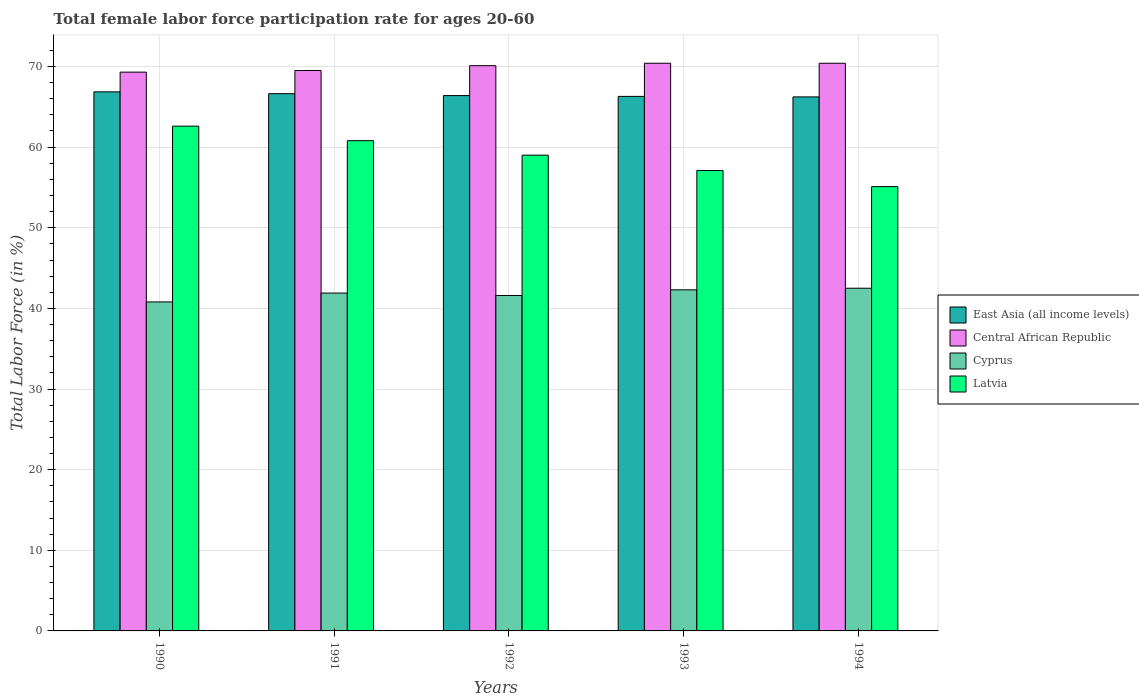How many different coloured bars are there?
Keep it short and to the point. 4. What is the label of the 1st group of bars from the left?
Make the answer very short. 1990. What is the female labor force participation rate in Central African Republic in 1992?
Your answer should be very brief. 70.1. Across all years, what is the maximum female labor force participation rate in Latvia?
Provide a succinct answer. 62.6. Across all years, what is the minimum female labor force participation rate in East Asia (all income levels)?
Make the answer very short. 66.23. In which year was the female labor force participation rate in Latvia maximum?
Provide a succinct answer. 1990. What is the total female labor force participation rate in Central African Republic in the graph?
Ensure brevity in your answer.  349.7. What is the difference between the female labor force participation rate in East Asia (all income levels) in 1991 and that in 1993?
Provide a succinct answer. 0.34. What is the difference between the female labor force participation rate in Cyprus in 1993 and the female labor force participation rate in Central African Republic in 1994?
Ensure brevity in your answer.  -28.1. What is the average female labor force participation rate in Latvia per year?
Give a very brief answer. 58.92. In the year 1992, what is the difference between the female labor force participation rate in East Asia (all income levels) and female labor force participation rate in Latvia?
Provide a short and direct response. 7.39. In how many years, is the female labor force participation rate in East Asia (all income levels) greater than 60 %?
Offer a very short reply. 5. What is the ratio of the female labor force participation rate in Central African Republic in 1991 to that in 1994?
Your answer should be compact. 0.99. Is the female labor force participation rate in East Asia (all income levels) in 1991 less than that in 1992?
Ensure brevity in your answer.  No. What is the difference between the highest and the second highest female labor force participation rate in East Asia (all income levels)?
Provide a succinct answer. 0.22. What is the difference between the highest and the lowest female labor force participation rate in Central African Republic?
Ensure brevity in your answer.  1.1. In how many years, is the female labor force participation rate in Central African Republic greater than the average female labor force participation rate in Central African Republic taken over all years?
Your answer should be very brief. 3. What does the 1st bar from the left in 1991 represents?
Keep it short and to the point. East Asia (all income levels). What does the 4th bar from the right in 1990 represents?
Offer a terse response. East Asia (all income levels). Are all the bars in the graph horizontal?
Provide a short and direct response. No. What is the difference between two consecutive major ticks on the Y-axis?
Provide a succinct answer. 10. Are the values on the major ticks of Y-axis written in scientific E-notation?
Offer a terse response. No. Does the graph contain any zero values?
Offer a very short reply. No. Where does the legend appear in the graph?
Your answer should be compact. Center right. How are the legend labels stacked?
Give a very brief answer. Vertical. What is the title of the graph?
Ensure brevity in your answer.  Total female labor force participation rate for ages 20-60. Does "Sao Tome and Principe" appear as one of the legend labels in the graph?
Offer a terse response. No. What is the Total Labor Force (in %) in East Asia (all income levels) in 1990?
Offer a very short reply. 66.85. What is the Total Labor Force (in %) of Central African Republic in 1990?
Your answer should be compact. 69.3. What is the Total Labor Force (in %) of Cyprus in 1990?
Provide a short and direct response. 40.8. What is the Total Labor Force (in %) of Latvia in 1990?
Give a very brief answer. 62.6. What is the Total Labor Force (in %) of East Asia (all income levels) in 1991?
Give a very brief answer. 66.63. What is the Total Labor Force (in %) in Central African Republic in 1991?
Your answer should be very brief. 69.5. What is the Total Labor Force (in %) in Cyprus in 1991?
Provide a short and direct response. 41.9. What is the Total Labor Force (in %) of Latvia in 1991?
Provide a succinct answer. 60.8. What is the Total Labor Force (in %) of East Asia (all income levels) in 1992?
Ensure brevity in your answer.  66.39. What is the Total Labor Force (in %) of Central African Republic in 1992?
Your answer should be compact. 70.1. What is the Total Labor Force (in %) of Cyprus in 1992?
Give a very brief answer. 41.6. What is the Total Labor Force (in %) in Latvia in 1992?
Your answer should be compact. 59. What is the Total Labor Force (in %) in East Asia (all income levels) in 1993?
Your answer should be very brief. 66.29. What is the Total Labor Force (in %) in Central African Republic in 1993?
Keep it short and to the point. 70.4. What is the Total Labor Force (in %) of Cyprus in 1993?
Provide a short and direct response. 42.3. What is the Total Labor Force (in %) of Latvia in 1993?
Your answer should be very brief. 57.1. What is the Total Labor Force (in %) of East Asia (all income levels) in 1994?
Keep it short and to the point. 66.23. What is the Total Labor Force (in %) of Central African Republic in 1994?
Keep it short and to the point. 70.4. What is the Total Labor Force (in %) of Cyprus in 1994?
Provide a short and direct response. 42.5. What is the Total Labor Force (in %) of Latvia in 1994?
Your answer should be compact. 55.1. Across all years, what is the maximum Total Labor Force (in %) of East Asia (all income levels)?
Ensure brevity in your answer.  66.85. Across all years, what is the maximum Total Labor Force (in %) in Central African Republic?
Offer a very short reply. 70.4. Across all years, what is the maximum Total Labor Force (in %) in Cyprus?
Make the answer very short. 42.5. Across all years, what is the maximum Total Labor Force (in %) of Latvia?
Offer a very short reply. 62.6. Across all years, what is the minimum Total Labor Force (in %) of East Asia (all income levels)?
Ensure brevity in your answer.  66.23. Across all years, what is the minimum Total Labor Force (in %) of Central African Republic?
Provide a short and direct response. 69.3. Across all years, what is the minimum Total Labor Force (in %) of Cyprus?
Your answer should be very brief. 40.8. Across all years, what is the minimum Total Labor Force (in %) of Latvia?
Keep it short and to the point. 55.1. What is the total Total Labor Force (in %) in East Asia (all income levels) in the graph?
Your answer should be very brief. 332.39. What is the total Total Labor Force (in %) of Central African Republic in the graph?
Your response must be concise. 349.7. What is the total Total Labor Force (in %) of Cyprus in the graph?
Provide a short and direct response. 209.1. What is the total Total Labor Force (in %) of Latvia in the graph?
Give a very brief answer. 294.6. What is the difference between the Total Labor Force (in %) of East Asia (all income levels) in 1990 and that in 1991?
Offer a very short reply. 0.22. What is the difference between the Total Labor Force (in %) in Central African Republic in 1990 and that in 1991?
Your answer should be compact. -0.2. What is the difference between the Total Labor Force (in %) in East Asia (all income levels) in 1990 and that in 1992?
Provide a short and direct response. 0.46. What is the difference between the Total Labor Force (in %) in Latvia in 1990 and that in 1992?
Your answer should be compact. 3.6. What is the difference between the Total Labor Force (in %) in East Asia (all income levels) in 1990 and that in 1993?
Make the answer very short. 0.56. What is the difference between the Total Labor Force (in %) of Central African Republic in 1990 and that in 1993?
Offer a very short reply. -1.1. What is the difference between the Total Labor Force (in %) of Cyprus in 1990 and that in 1993?
Offer a terse response. -1.5. What is the difference between the Total Labor Force (in %) in East Asia (all income levels) in 1990 and that in 1994?
Provide a succinct answer. 0.62. What is the difference between the Total Labor Force (in %) in Central African Republic in 1990 and that in 1994?
Keep it short and to the point. -1.1. What is the difference between the Total Labor Force (in %) of Cyprus in 1990 and that in 1994?
Your response must be concise. -1.7. What is the difference between the Total Labor Force (in %) of East Asia (all income levels) in 1991 and that in 1992?
Your response must be concise. 0.24. What is the difference between the Total Labor Force (in %) in Cyprus in 1991 and that in 1992?
Your answer should be very brief. 0.3. What is the difference between the Total Labor Force (in %) of Latvia in 1991 and that in 1992?
Your response must be concise. 1.8. What is the difference between the Total Labor Force (in %) of East Asia (all income levels) in 1991 and that in 1993?
Offer a terse response. 0.34. What is the difference between the Total Labor Force (in %) of Latvia in 1991 and that in 1993?
Keep it short and to the point. 3.7. What is the difference between the Total Labor Force (in %) of East Asia (all income levels) in 1991 and that in 1994?
Provide a succinct answer. 0.4. What is the difference between the Total Labor Force (in %) of Cyprus in 1991 and that in 1994?
Offer a terse response. -0.6. What is the difference between the Total Labor Force (in %) of East Asia (all income levels) in 1992 and that in 1993?
Offer a very short reply. 0.1. What is the difference between the Total Labor Force (in %) of Latvia in 1992 and that in 1993?
Offer a very short reply. 1.9. What is the difference between the Total Labor Force (in %) in East Asia (all income levels) in 1992 and that in 1994?
Ensure brevity in your answer.  0.16. What is the difference between the Total Labor Force (in %) in Central African Republic in 1992 and that in 1994?
Provide a succinct answer. -0.3. What is the difference between the Total Labor Force (in %) of Latvia in 1992 and that in 1994?
Offer a terse response. 3.9. What is the difference between the Total Labor Force (in %) of East Asia (all income levels) in 1993 and that in 1994?
Provide a short and direct response. 0.06. What is the difference between the Total Labor Force (in %) in Latvia in 1993 and that in 1994?
Provide a succinct answer. 2. What is the difference between the Total Labor Force (in %) of East Asia (all income levels) in 1990 and the Total Labor Force (in %) of Central African Republic in 1991?
Give a very brief answer. -2.65. What is the difference between the Total Labor Force (in %) in East Asia (all income levels) in 1990 and the Total Labor Force (in %) in Cyprus in 1991?
Ensure brevity in your answer.  24.95. What is the difference between the Total Labor Force (in %) of East Asia (all income levels) in 1990 and the Total Labor Force (in %) of Latvia in 1991?
Keep it short and to the point. 6.05. What is the difference between the Total Labor Force (in %) of Central African Republic in 1990 and the Total Labor Force (in %) of Cyprus in 1991?
Your answer should be very brief. 27.4. What is the difference between the Total Labor Force (in %) of Cyprus in 1990 and the Total Labor Force (in %) of Latvia in 1991?
Your response must be concise. -20. What is the difference between the Total Labor Force (in %) in East Asia (all income levels) in 1990 and the Total Labor Force (in %) in Central African Republic in 1992?
Provide a succinct answer. -3.25. What is the difference between the Total Labor Force (in %) of East Asia (all income levels) in 1990 and the Total Labor Force (in %) of Cyprus in 1992?
Your answer should be compact. 25.25. What is the difference between the Total Labor Force (in %) in East Asia (all income levels) in 1990 and the Total Labor Force (in %) in Latvia in 1992?
Give a very brief answer. 7.85. What is the difference between the Total Labor Force (in %) in Central African Republic in 1990 and the Total Labor Force (in %) in Cyprus in 1992?
Give a very brief answer. 27.7. What is the difference between the Total Labor Force (in %) of Central African Republic in 1990 and the Total Labor Force (in %) of Latvia in 1992?
Provide a short and direct response. 10.3. What is the difference between the Total Labor Force (in %) of Cyprus in 1990 and the Total Labor Force (in %) of Latvia in 1992?
Make the answer very short. -18.2. What is the difference between the Total Labor Force (in %) in East Asia (all income levels) in 1990 and the Total Labor Force (in %) in Central African Republic in 1993?
Give a very brief answer. -3.55. What is the difference between the Total Labor Force (in %) of East Asia (all income levels) in 1990 and the Total Labor Force (in %) of Cyprus in 1993?
Your answer should be compact. 24.55. What is the difference between the Total Labor Force (in %) of East Asia (all income levels) in 1990 and the Total Labor Force (in %) of Latvia in 1993?
Offer a very short reply. 9.75. What is the difference between the Total Labor Force (in %) in Central African Republic in 1990 and the Total Labor Force (in %) in Cyprus in 1993?
Provide a short and direct response. 27. What is the difference between the Total Labor Force (in %) of Cyprus in 1990 and the Total Labor Force (in %) of Latvia in 1993?
Your response must be concise. -16.3. What is the difference between the Total Labor Force (in %) of East Asia (all income levels) in 1990 and the Total Labor Force (in %) of Central African Republic in 1994?
Give a very brief answer. -3.55. What is the difference between the Total Labor Force (in %) of East Asia (all income levels) in 1990 and the Total Labor Force (in %) of Cyprus in 1994?
Your answer should be very brief. 24.35. What is the difference between the Total Labor Force (in %) in East Asia (all income levels) in 1990 and the Total Labor Force (in %) in Latvia in 1994?
Offer a terse response. 11.75. What is the difference between the Total Labor Force (in %) of Central African Republic in 1990 and the Total Labor Force (in %) of Cyprus in 1994?
Keep it short and to the point. 26.8. What is the difference between the Total Labor Force (in %) in Cyprus in 1990 and the Total Labor Force (in %) in Latvia in 1994?
Ensure brevity in your answer.  -14.3. What is the difference between the Total Labor Force (in %) in East Asia (all income levels) in 1991 and the Total Labor Force (in %) in Central African Republic in 1992?
Provide a succinct answer. -3.47. What is the difference between the Total Labor Force (in %) in East Asia (all income levels) in 1991 and the Total Labor Force (in %) in Cyprus in 1992?
Keep it short and to the point. 25.03. What is the difference between the Total Labor Force (in %) of East Asia (all income levels) in 1991 and the Total Labor Force (in %) of Latvia in 1992?
Make the answer very short. 7.63. What is the difference between the Total Labor Force (in %) of Central African Republic in 1991 and the Total Labor Force (in %) of Cyprus in 1992?
Give a very brief answer. 27.9. What is the difference between the Total Labor Force (in %) in Central African Republic in 1991 and the Total Labor Force (in %) in Latvia in 1992?
Offer a terse response. 10.5. What is the difference between the Total Labor Force (in %) of Cyprus in 1991 and the Total Labor Force (in %) of Latvia in 1992?
Give a very brief answer. -17.1. What is the difference between the Total Labor Force (in %) of East Asia (all income levels) in 1991 and the Total Labor Force (in %) of Central African Republic in 1993?
Your answer should be very brief. -3.77. What is the difference between the Total Labor Force (in %) of East Asia (all income levels) in 1991 and the Total Labor Force (in %) of Cyprus in 1993?
Give a very brief answer. 24.33. What is the difference between the Total Labor Force (in %) of East Asia (all income levels) in 1991 and the Total Labor Force (in %) of Latvia in 1993?
Offer a very short reply. 9.53. What is the difference between the Total Labor Force (in %) in Central African Republic in 1991 and the Total Labor Force (in %) in Cyprus in 1993?
Keep it short and to the point. 27.2. What is the difference between the Total Labor Force (in %) in Cyprus in 1991 and the Total Labor Force (in %) in Latvia in 1993?
Ensure brevity in your answer.  -15.2. What is the difference between the Total Labor Force (in %) in East Asia (all income levels) in 1991 and the Total Labor Force (in %) in Central African Republic in 1994?
Provide a succinct answer. -3.77. What is the difference between the Total Labor Force (in %) of East Asia (all income levels) in 1991 and the Total Labor Force (in %) of Cyprus in 1994?
Offer a very short reply. 24.13. What is the difference between the Total Labor Force (in %) of East Asia (all income levels) in 1991 and the Total Labor Force (in %) of Latvia in 1994?
Your answer should be compact. 11.53. What is the difference between the Total Labor Force (in %) of Central African Republic in 1991 and the Total Labor Force (in %) of Cyprus in 1994?
Your answer should be compact. 27. What is the difference between the Total Labor Force (in %) of Cyprus in 1991 and the Total Labor Force (in %) of Latvia in 1994?
Offer a terse response. -13.2. What is the difference between the Total Labor Force (in %) in East Asia (all income levels) in 1992 and the Total Labor Force (in %) in Central African Republic in 1993?
Provide a short and direct response. -4.01. What is the difference between the Total Labor Force (in %) in East Asia (all income levels) in 1992 and the Total Labor Force (in %) in Cyprus in 1993?
Provide a succinct answer. 24.09. What is the difference between the Total Labor Force (in %) of East Asia (all income levels) in 1992 and the Total Labor Force (in %) of Latvia in 1993?
Provide a short and direct response. 9.29. What is the difference between the Total Labor Force (in %) of Central African Republic in 1992 and the Total Labor Force (in %) of Cyprus in 1993?
Offer a terse response. 27.8. What is the difference between the Total Labor Force (in %) of Central African Republic in 1992 and the Total Labor Force (in %) of Latvia in 1993?
Offer a very short reply. 13. What is the difference between the Total Labor Force (in %) in Cyprus in 1992 and the Total Labor Force (in %) in Latvia in 1993?
Provide a short and direct response. -15.5. What is the difference between the Total Labor Force (in %) of East Asia (all income levels) in 1992 and the Total Labor Force (in %) of Central African Republic in 1994?
Ensure brevity in your answer.  -4.01. What is the difference between the Total Labor Force (in %) in East Asia (all income levels) in 1992 and the Total Labor Force (in %) in Cyprus in 1994?
Provide a short and direct response. 23.89. What is the difference between the Total Labor Force (in %) of East Asia (all income levels) in 1992 and the Total Labor Force (in %) of Latvia in 1994?
Offer a terse response. 11.29. What is the difference between the Total Labor Force (in %) of Central African Republic in 1992 and the Total Labor Force (in %) of Cyprus in 1994?
Offer a terse response. 27.6. What is the difference between the Total Labor Force (in %) of Central African Republic in 1992 and the Total Labor Force (in %) of Latvia in 1994?
Ensure brevity in your answer.  15. What is the difference between the Total Labor Force (in %) in East Asia (all income levels) in 1993 and the Total Labor Force (in %) in Central African Republic in 1994?
Give a very brief answer. -4.11. What is the difference between the Total Labor Force (in %) of East Asia (all income levels) in 1993 and the Total Labor Force (in %) of Cyprus in 1994?
Offer a very short reply. 23.79. What is the difference between the Total Labor Force (in %) of East Asia (all income levels) in 1993 and the Total Labor Force (in %) of Latvia in 1994?
Ensure brevity in your answer.  11.19. What is the difference between the Total Labor Force (in %) in Central African Republic in 1993 and the Total Labor Force (in %) in Cyprus in 1994?
Provide a short and direct response. 27.9. What is the difference between the Total Labor Force (in %) of Central African Republic in 1993 and the Total Labor Force (in %) of Latvia in 1994?
Give a very brief answer. 15.3. What is the difference between the Total Labor Force (in %) in Cyprus in 1993 and the Total Labor Force (in %) in Latvia in 1994?
Provide a succinct answer. -12.8. What is the average Total Labor Force (in %) in East Asia (all income levels) per year?
Provide a short and direct response. 66.48. What is the average Total Labor Force (in %) in Central African Republic per year?
Make the answer very short. 69.94. What is the average Total Labor Force (in %) in Cyprus per year?
Keep it short and to the point. 41.82. What is the average Total Labor Force (in %) of Latvia per year?
Give a very brief answer. 58.92. In the year 1990, what is the difference between the Total Labor Force (in %) in East Asia (all income levels) and Total Labor Force (in %) in Central African Republic?
Your answer should be compact. -2.45. In the year 1990, what is the difference between the Total Labor Force (in %) of East Asia (all income levels) and Total Labor Force (in %) of Cyprus?
Make the answer very short. 26.05. In the year 1990, what is the difference between the Total Labor Force (in %) of East Asia (all income levels) and Total Labor Force (in %) of Latvia?
Keep it short and to the point. 4.25. In the year 1990, what is the difference between the Total Labor Force (in %) in Cyprus and Total Labor Force (in %) in Latvia?
Keep it short and to the point. -21.8. In the year 1991, what is the difference between the Total Labor Force (in %) in East Asia (all income levels) and Total Labor Force (in %) in Central African Republic?
Offer a very short reply. -2.87. In the year 1991, what is the difference between the Total Labor Force (in %) in East Asia (all income levels) and Total Labor Force (in %) in Cyprus?
Your answer should be very brief. 24.73. In the year 1991, what is the difference between the Total Labor Force (in %) in East Asia (all income levels) and Total Labor Force (in %) in Latvia?
Offer a very short reply. 5.83. In the year 1991, what is the difference between the Total Labor Force (in %) of Central African Republic and Total Labor Force (in %) of Cyprus?
Provide a short and direct response. 27.6. In the year 1991, what is the difference between the Total Labor Force (in %) in Central African Republic and Total Labor Force (in %) in Latvia?
Your response must be concise. 8.7. In the year 1991, what is the difference between the Total Labor Force (in %) in Cyprus and Total Labor Force (in %) in Latvia?
Make the answer very short. -18.9. In the year 1992, what is the difference between the Total Labor Force (in %) in East Asia (all income levels) and Total Labor Force (in %) in Central African Republic?
Provide a short and direct response. -3.71. In the year 1992, what is the difference between the Total Labor Force (in %) in East Asia (all income levels) and Total Labor Force (in %) in Cyprus?
Offer a terse response. 24.79. In the year 1992, what is the difference between the Total Labor Force (in %) of East Asia (all income levels) and Total Labor Force (in %) of Latvia?
Your response must be concise. 7.39. In the year 1992, what is the difference between the Total Labor Force (in %) of Central African Republic and Total Labor Force (in %) of Latvia?
Provide a succinct answer. 11.1. In the year 1992, what is the difference between the Total Labor Force (in %) in Cyprus and Total Labor Force (in %) in Latvia?
Offer a terse response. -17.4. In the year 1993, what is the difference between the Total Labor Force (in %) of East Asia (all income levels) and Total Labor Force (in %) of Central African Republic?
Offer a very short reply. -4.11. In the year 1993, what is the difference between the Total Labor Force (in %) of East Asia (all income levels) and Total Labor Force (in %) of Cyprus?
Provide a short and direct response. 23.99. In the year 1993, what is the difference between the Total Labor Force (in %) in East Asia (all income levels) and Total Labor Force (in %) in Latvia?
Your answer should be compact. 9.19. In the year 1993, what is the difference between the Total Labor Force (in %) in Central African Republic and Total Labor Force (in %) in Cyprus?
Give a very brief answer. 28.1. In the year 1993, what is the difference between the Total Labor Force (in %) of Cyprus and Total Labor Force (in %) of Latvia?
Your answer should be compact. -14.8. In the year 1994, what is the difference between the Total Labor Force (in %) of East Asia (all income levels) and Total Labor Force (in %) of Central African Republic?
Your answer should be compact. -4.17. In the year 1994, what is the difference between the Total Labor Force (in %) in East Asia (all income levels) and Total Labor Force (in %) in Cyprus?
Offer a very short reply. 23.73. In the year 1994, what is the difference between the Total Labor Force (in %) of East Asia (all income levels) and Total Labor Force (in %) of Latvia?
Offer a very short reply. 11.13. In the year 1994, what is the difference between the Total Labor Force (in %) of Central African Republic and Total Labor Force (in %) of Cyprus?
Ensure brevity in your answer.  27.9. In the year 1994, what is the difference between the Total Labor Force (in %) of Cyprus and Total Labor Force (in %) of Latvia?
Provide a succinct answer. -12.6. What is the ratio of the Total Labor Force (in %) of East Asia (all income levels) in 1990 to that in 1991?
Offer a terse response. 1. What is the ratio of the Total Labor Force (in %) of Central African Republic in 1990 to that in 1991?
Offer a terse response. 1. What is the ratio of the Total Labor Force (in %) of Cyprus in 1990 to that in 1991?
Ensure brevity in your answer.  0.97. What is the ratio of the Total Labor Force (in %) in Latvia in 1990 to that in 1991?
Your response must be concise. 1.03. What is the ratio of the Total Labor Force (in %) of Cyprus in 1990 to that in 1992?
Your answer should be compact. 0.98. What is the ratio of the Total Labor Force (in %) in Latvia in 1990 to that in 1992?
Your response must be concise. 1.06. What is the ratio of the Total Labor Force (in %) in East Asia (all income levels) in 1990 to that in 1993?
Offer a very short reply. 1.01. What is the ratio of the Total Labor Force (in %) in Central African Republic in 1990 to that in 1993?
Your response must be concise. 0.98. What is the ratio of the Total Labor Force (in %) in Cyprus in 1990 to that in 1993?
Provide a succinct answer. 0.96. What is the ratio of the Total Labor Force (in %) of Latvia in 1990 to that in 1993?
Give a very brief answer. 1.1. What is the ratio of the Total Labor Force (in %) in East Asia (all income levels) in 1990 to that in 1994?
Keep it short and to the point. 1.01. What is the ratio of the Total Labor Force (in %) of Central African Republic in 1990 to that in 1994?
Your response must be concise. 0.98. What is the ratio of the Total Labor Force (in %) of Latvia in 1990 to that in 1994?
Provide a short and direct response. 1.14. What is the ratio of the Total Labor Force (in %) of East Asia (all income levels) in 1991 to that in 1992?
Offer a terse response. 1. What is the ratio of the Total Labor Force (in %) in Central African Republic in 1991 to that in 1992?
Your answer should be very brief. 0.99. What is the ratio of the Total Labor Force (in %) in Cyprus in 1991 to that in 1992?
Your answer should be very brief. 1.01. What is the ratio of the Total Labor Force (in %) in Latvia in 1991 to that in 1992?
Your answer should be very brief. 1.03. What is the ratio of the Total Labor Force (in %) in East Asia (all income levels) in 1991 to that in 1993?
Your answer should be compact. 1.01. What is the ratio of the Total Labor Force (in %) in Central African Republic in 1991 to that in 1993?
Offer a very short reply. 0.99. What is the ratio of the Total Labor Force (in %) of Cyprus in 1991 to that in 1993?
Make the answer very short. 0.99. What is the ratio of the Total Labor Force (in %) in Latvia in 1991 to that in 1993?
Provide a succinct answer. 1.06. What is the ratio of the Total Labor Force (in %) of Central African Republic in 1991 to that in 1994?
Ensure brevity in your answer.  0.99. What is the ratio of the Total Labor Force (in %) in Cyprus in 1991 to that in 1994?
Provide a short and direct response. 0.99. What is the ratio of the Total Labor Force (in %) in Latvia in 1991 to that in 1994?
Your answer should be compact. 1.1. What is the ratio of the Total Labor Force (in %) in Central African Republic in 1992 to that in 1993?
Keep it short and to the point. 1. What is the ratio of the Total Labor Force (in %) of Cyprus in 1992 to that in 1993?
Ensure brevity in your answer.  0.98. What is the ratio of the Total Labor Force (in %) of Latvia in 1992 to that in 1993?
Give a very brief answer. 1.03. What is the ratio of the Total Labor Force (in %) in East Asia (all income levels) in 1992 to that in 1994?
Give a very brief answer. 1. What is the ratio of the Total Labor Force (in %) of Central African Republic in 1992 to that in 1994?
Give a very brief answer. 1. What is the ratio of the Total Labor Force (in %) in Cyprus in 1992 to that in 1994?
Provide a succinct answer. 0.98. What is the ratio of the Total Labor Force (in %) in Latvia in 1992 to that in 1994?
Offer a terse response. 1.07. What is the ratio of the Total Labor Force (in %) of Central African Republic in 1993 to that in 1994?
Provide a short and direct response. 1. What is the ratio of the Total Labor Force (in %) of Latvia in 1993 to that in 1994?
Your response must be concise. 1.04. What is the difference between the highest and the second highest Total Labor Force (in %) of East Asia (all income levels)?
Offer a terse response. 0.22. What is the difference between the highest and the lowest Total Labor Force (in %) of East Asia (all income levels)?
Make the answer very short. 0.62. What is the difference between the highest and the lowest Total Labor Force (in %) in Cyprus?
Ensure brevity in your answer.  1.7. 